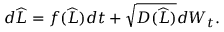<formula> <loc_0><loc_0><loc_500><loc_500>\begin{array} { r } { d \widehat { L } = f ( \widehat { L } ) d t + \sqrt { D ( \widehat { L } ) } d W _ { t } . } \end{array}</formula> 